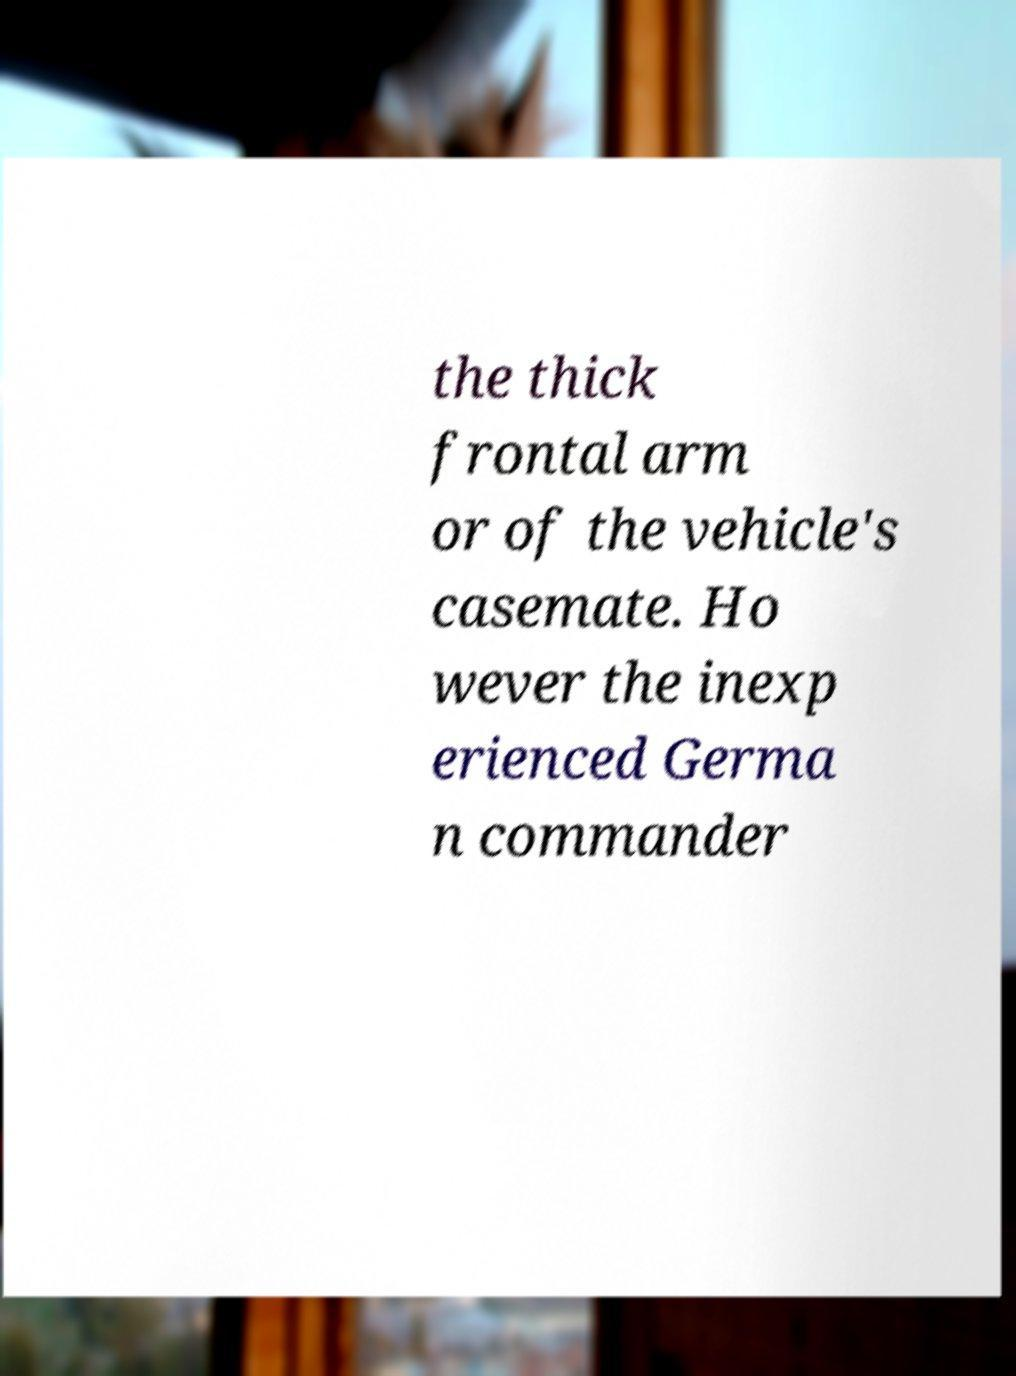Can you read and provide the text displayed in the image?This photo seems to have some interesting text. Can you extract and type it out for me? the thick frontal arm or of the vehicle's casemate. Ho wever the inexp erienced Germa n commander 